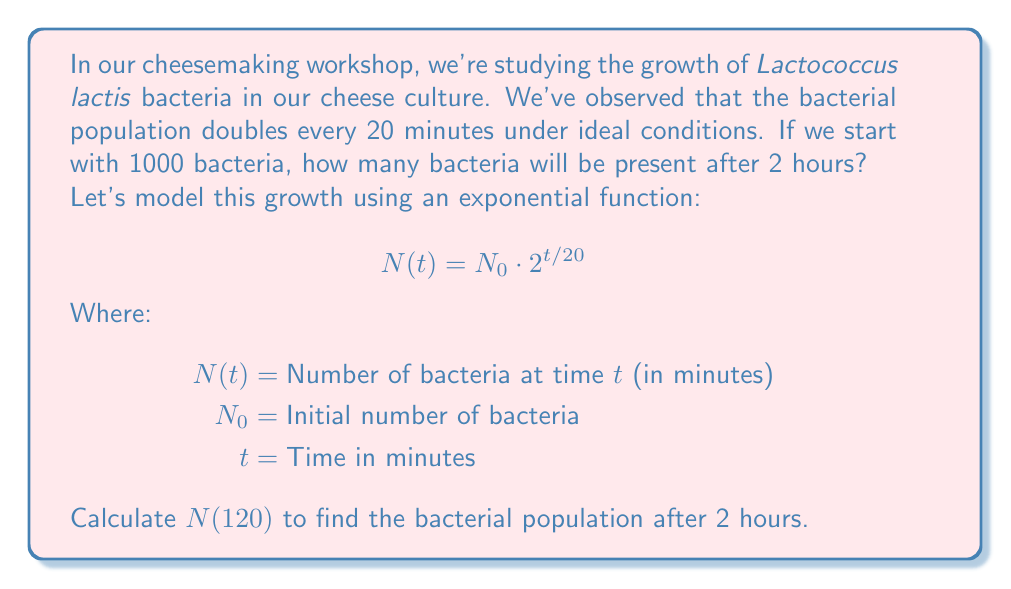Help me with this question. Let's solve this step-by-step:

1) We're given:
   $N_0 = 1000$ (initial bacteria)
   $t = 120$ minutes (2 hours)

2) We'll use the exponential growth model:
   $$N(t) = N_0 \cdot 2^{t/20}$$

3) Substitute the values:
   $$N(120) = 1000 \cdot 2^{120/20}$$

4) Simplify the exponent:
   $$N(120) = 1000 \cdot 2^6$$

5) Calculate $2^6$:
   $$N(120) = 1000 \cdot 64$$

6) Multiply:
   $$N(120) = 64000$$

Therefore, after 2 hours, there will be 64,000 bacteria in the cheese culture.
Answer: 64,000 bacteria 